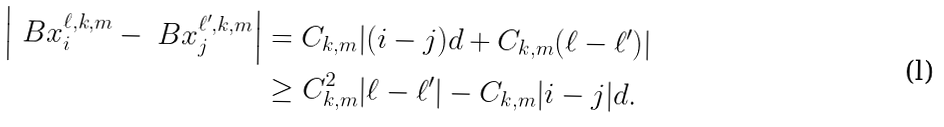Convert formula to latex. <formula><loc_0><loc_0><loc_500><loc_500>\left | \ B x ^ { \ell , k , m } _ { i } - \ B x ^ { \ell ^ { \prime } , k , m } _ { j } \right | & = C _ { k , m } | ( i - j ) d + C _ { k , m } ( \ell - \ell ^ { \prime } ) | \\ & \geq C _ { k , m } ^ { 2 } | \ell - \ell ^ { \prime } | - C _ { k , m } | i - j | d .</formula> 